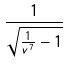<formula> <loc_0><loc_0><loc_500><loc_500>\frac { 1 } { \sqrt { \frac { 1 } { v ^ { 7 } } - 1 } }</formula> 